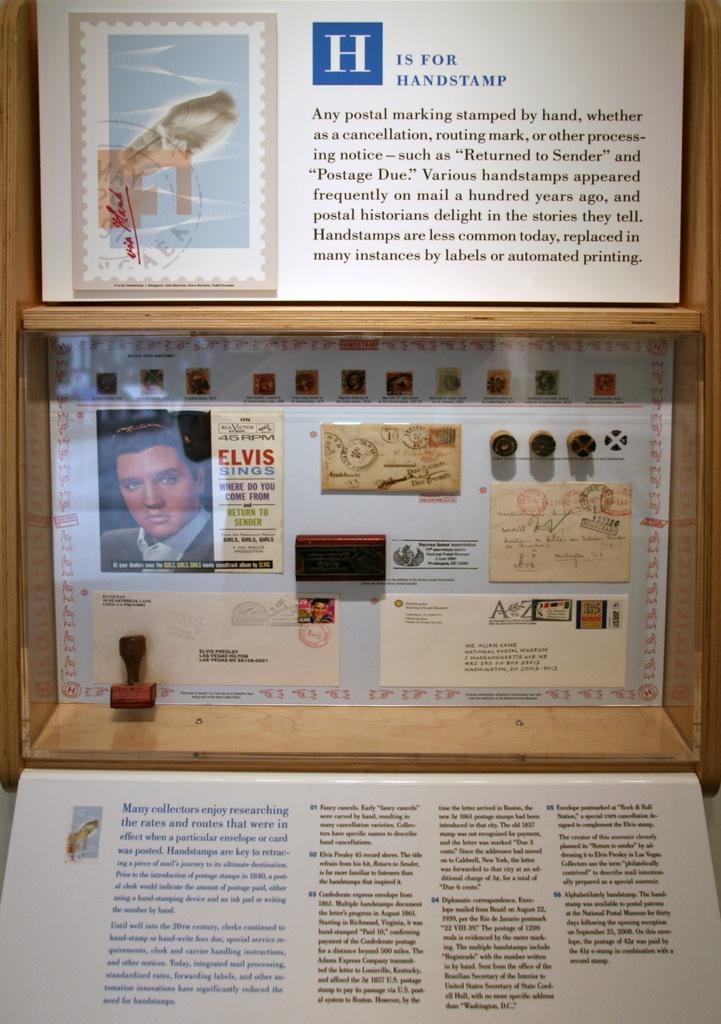<image>
Describe the image concisely. The article shown speaks about the king of rock and rolel Elvis Presley. 